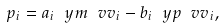<formula> <loc_0><loc_0><loc_500><loc_500>p _ { i } = a _ { i } \ y m { \ v v _ { i } } - b _ { i } \ y p { \ v v _ { i } } ,</formula> 